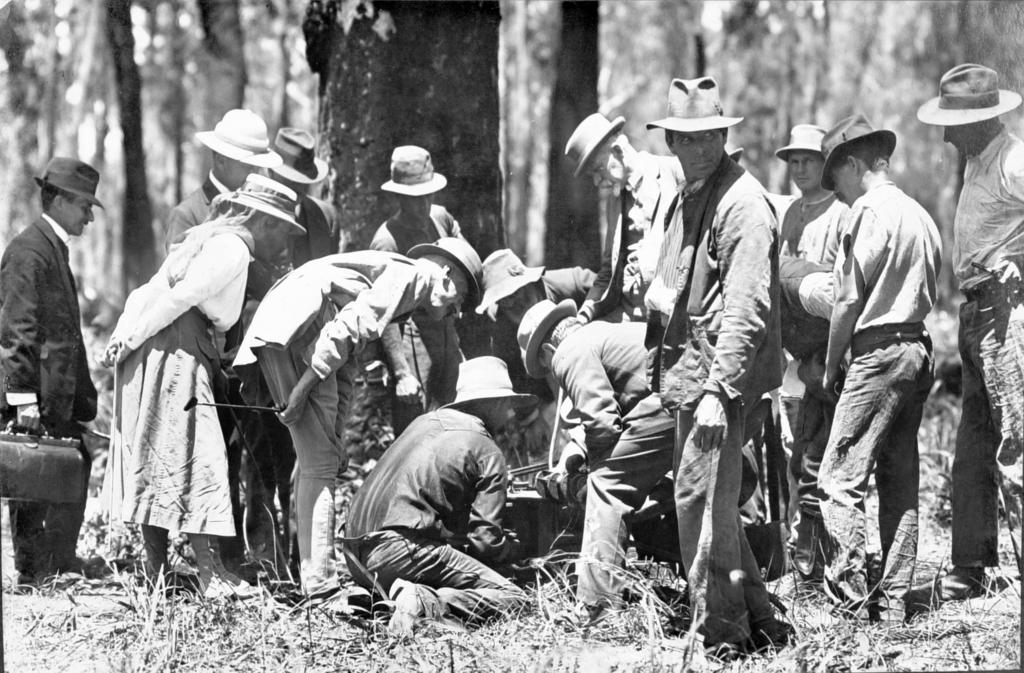How many people are in the image? There are people in the image. Where are the people located? The people are on the grass. What are the people wearing on their heads? The people are wearing hats. What is one person holding in the image? One person is holding a bag. What type of vegetation is visible in the image? There are trees in the image. What object can be seen on the ground? There is an object on the ground. How many crayons are being distributed by the person in the image? There is no mention of crayons or distribution in the image. 